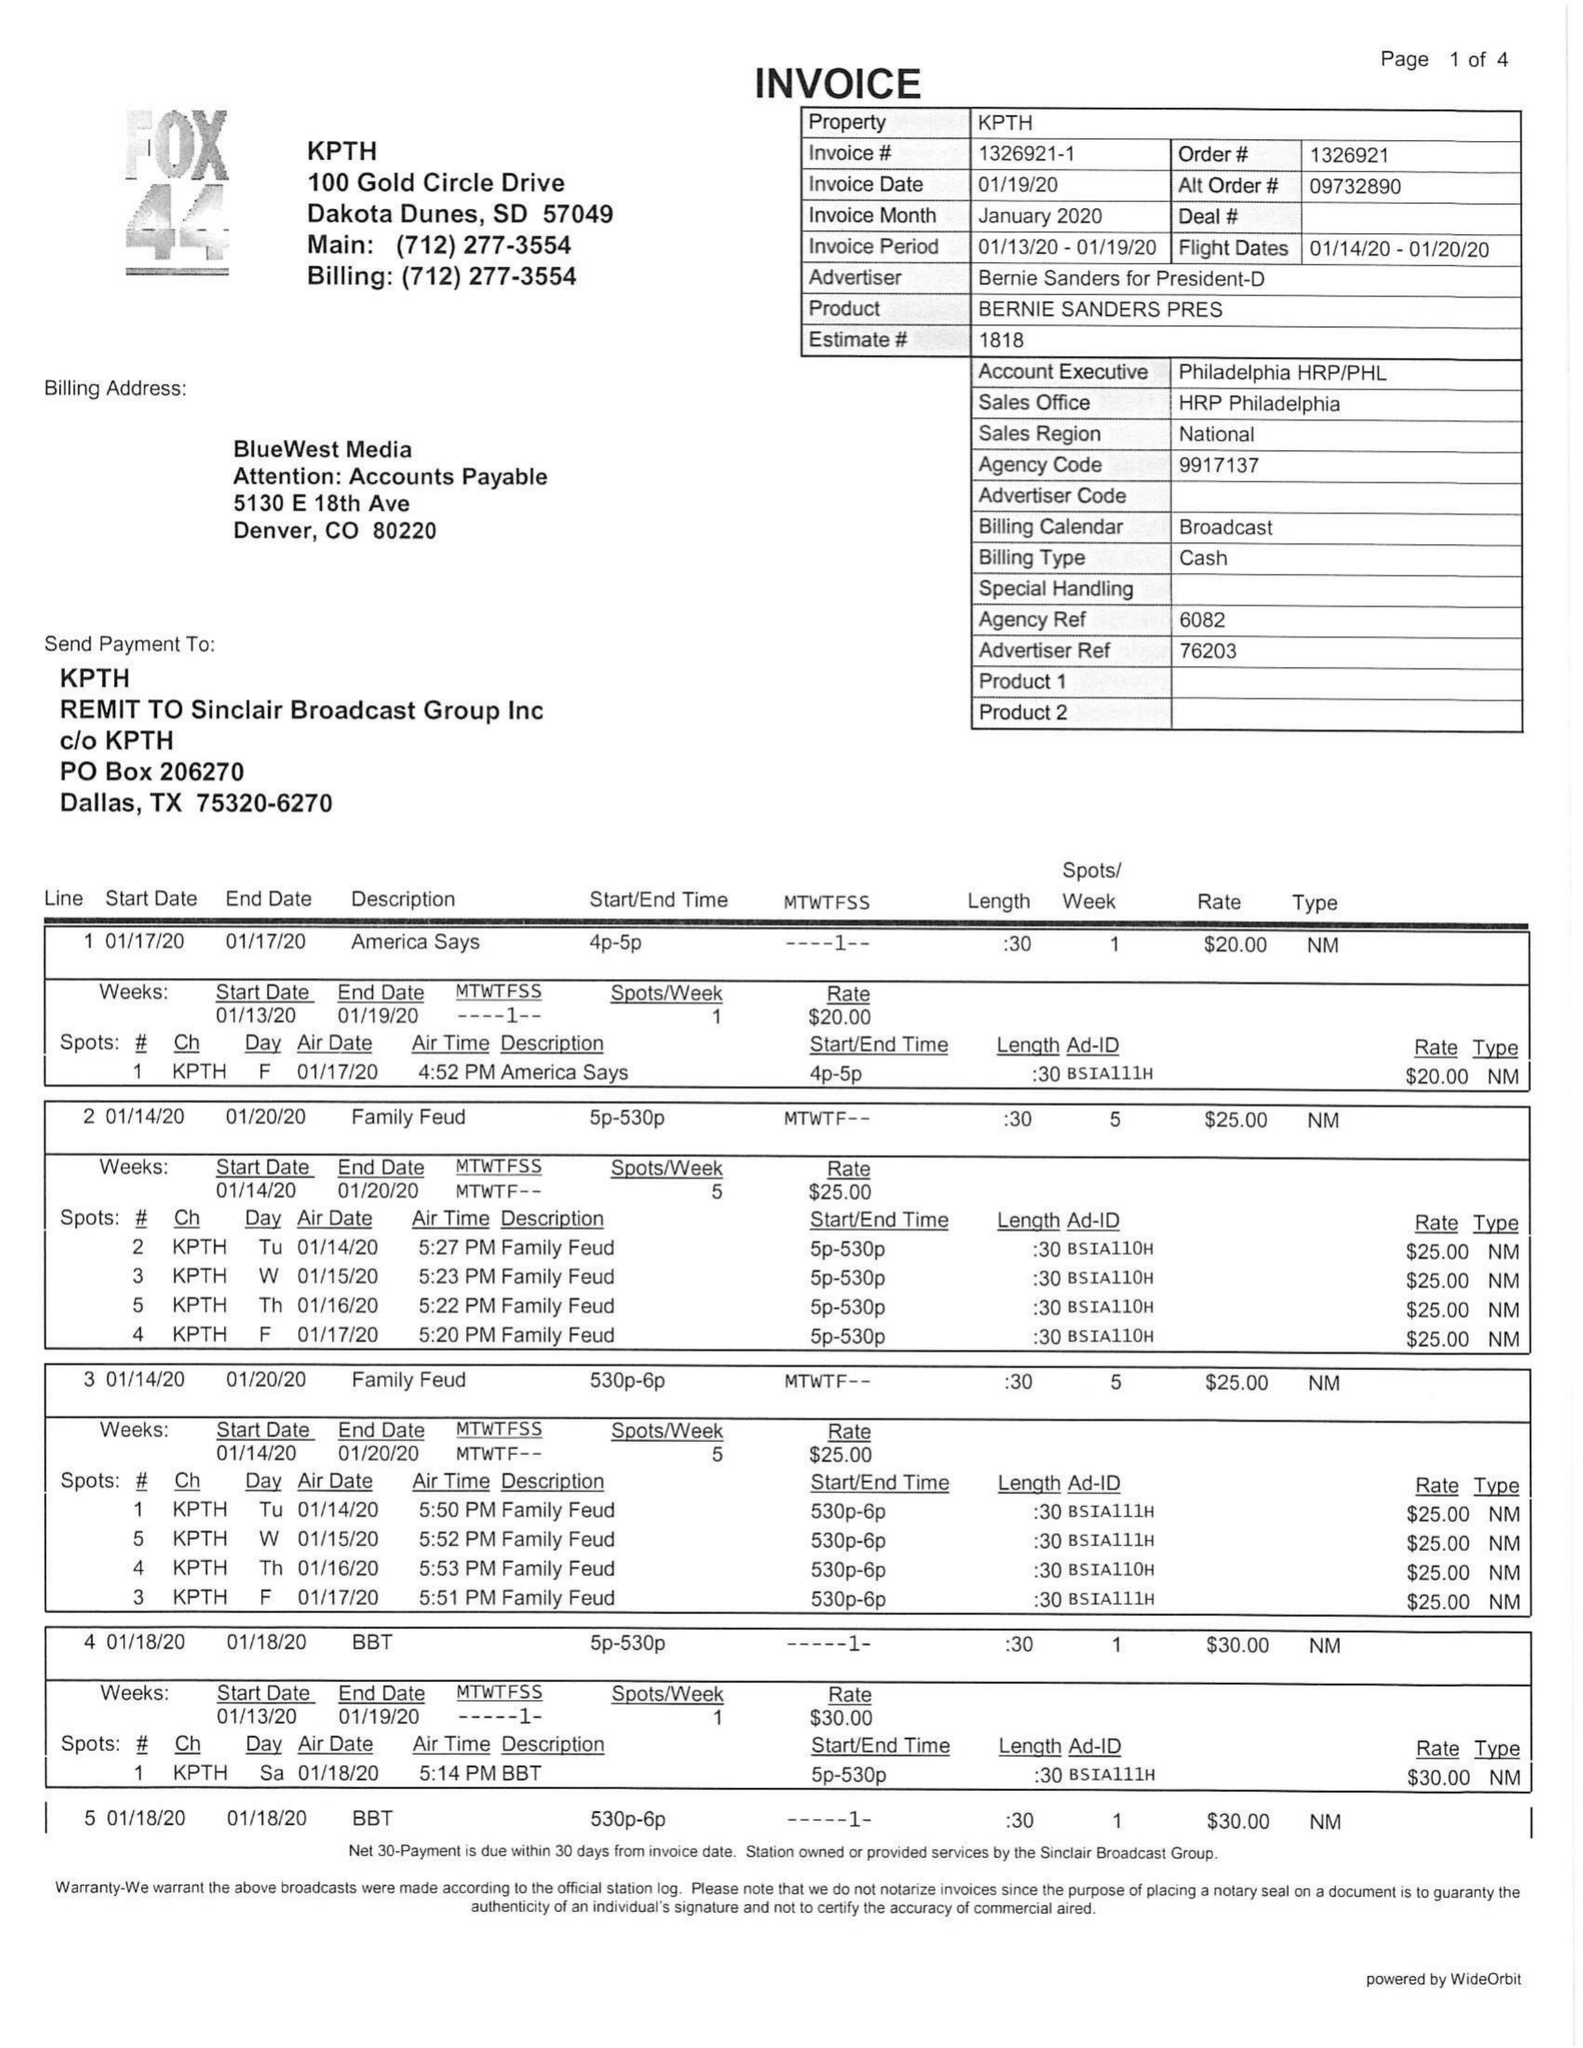What is the value for the contract_num?
Answer the question using a single word or phrase. 1326921 